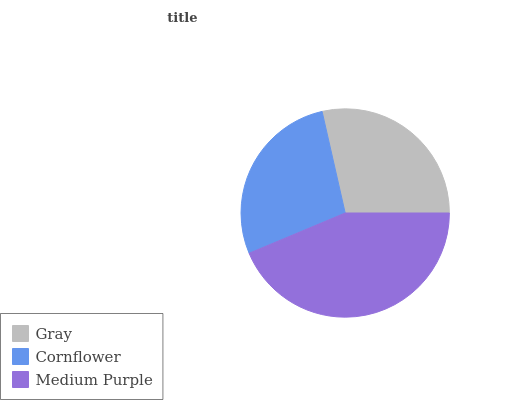Is Cornflower the minimum?
Answer yes or no. Yes. Is Medium Purple the maximum?
Answer yes or no. Yes. Is Medium Purple the minimum?
Answer yes or no. No. Is Cornflower the maximum?
Answer yes or no. No. Is Medium Purple greater than Cornflower?
Answer yes or no. Yes. Is Cornflower less than Medium Purple?
Answer yes or no. Yes. Is Cornflower greater than Medium Purple?
Answer yes or no. No. Is Medium Purple less than Cornflower?
Answer yes or no. No. Is Gray the high median?
Answer yes or no. Yes. Is Gray the low median?
Answer yes or no. Yes. Is Medium Purple the high median?
Answer yes or no. No. Is Cornflower the low median?
Answer yes or no. No. 